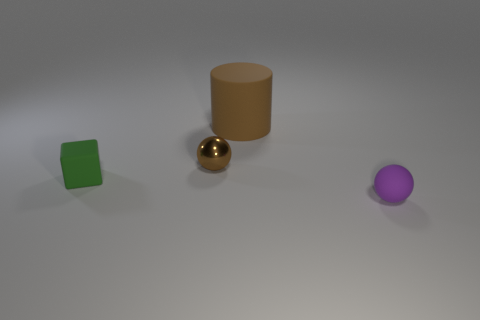Subtract all purple spheres. How many spheres are left? 1 Add 1 big brown rubber things. How many objects exist? 5 Subtract 1 cylinders. How many cylinders are left? 0 Subtract all cubes. How many objects are left? 3 Subtract 0 red balls. How many objects are left? 4 Subtract all yellow cylinders. Subtract all purple cubes. How many cylinders are left? 1 Subtract all purple matte cylinders. Subtract all green rubber things. How many objects are left? 3 Add 3 purple objects. How many purple objects are left? 4 Add 4 large cyan rubber balls. How many large cyan rubber balls exist? 4 